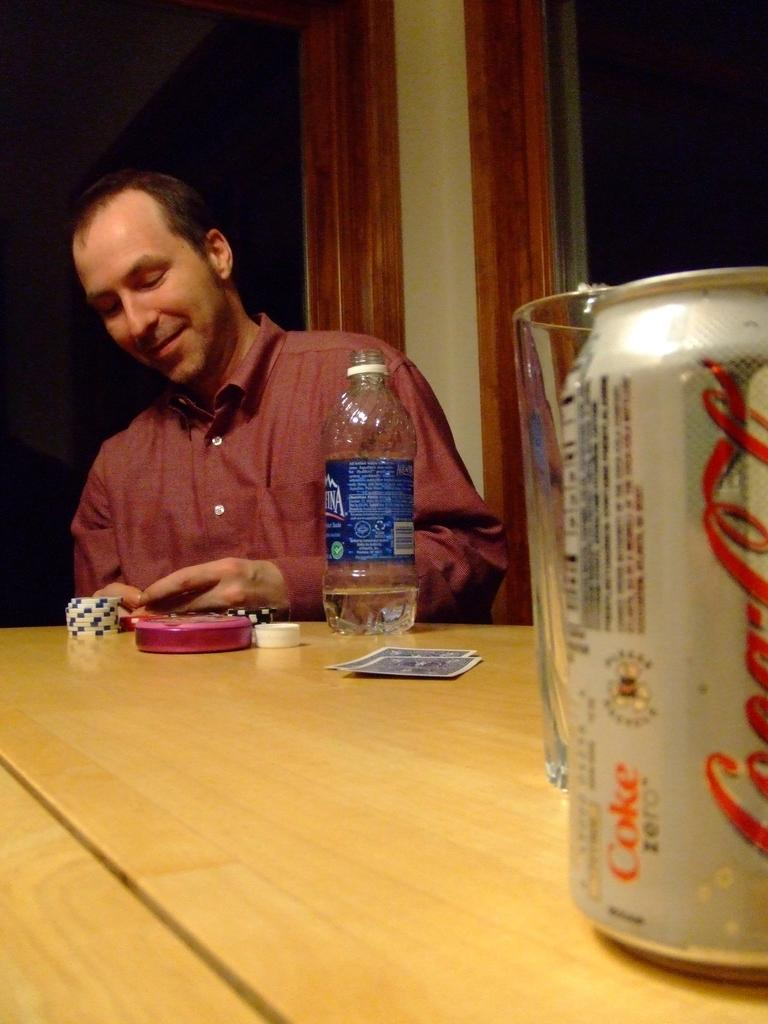<image>
Give a short and clear explanation of the subsequent image. Man is gambling while having a can of Coca Cola and a bottle of Aquafina Water. 